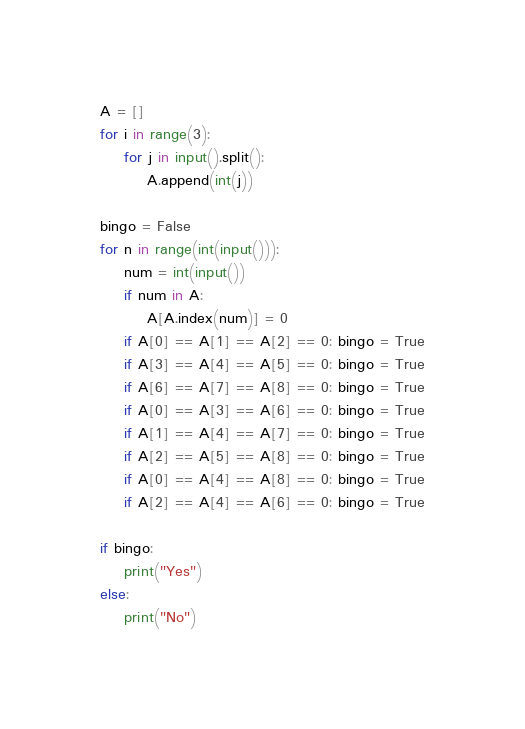<code> <loc_0><loc_0><loc_500><loc_500><_Python_>A = []
for i in range(3):
    for j in input().split():
        A.append(int(j))

bingo = False
for n in range(int(input())):
    num = int(input())
    if num in A:
        A[A.index(num)] = 0
    if A[0] == A[1] == A[2] == 0: bingo = True
    if A[3] == A[4] == A[5] == 0: bingo = True
    if A[6] == A[7] == A[8] == 0: bingo = True
    if A[0] == A[3] == A[6] == 0: bingo = True
    if A[1] == A[4] == A[7] == 0: bingo = True
    if A[2] == A[5] == A[8] == 0: bingo = True
    if A[0] == A[4] == A[8] == 0: bingo = True
    if A[2] == A[4] == A[6] == 0: bingo = True

if bingo:
    print("Yes")
else:
    print("No")</code> 